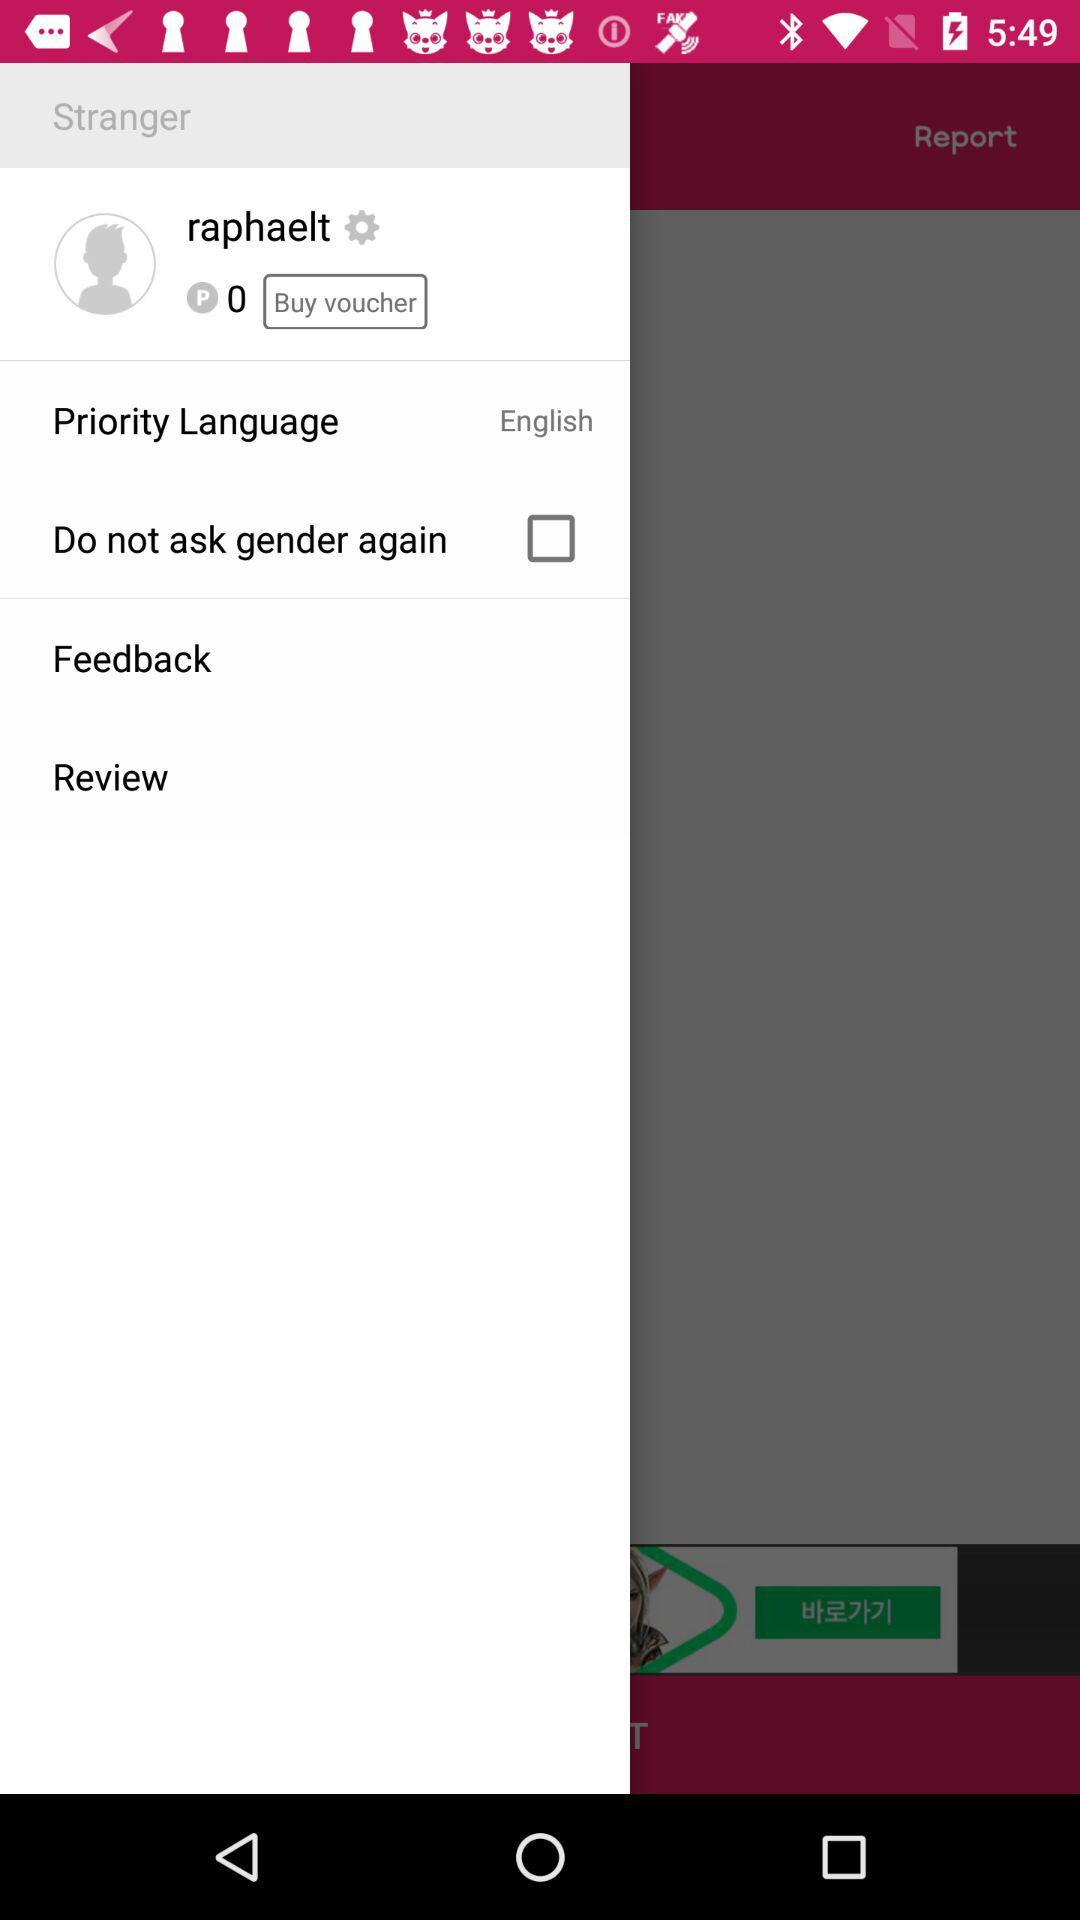What is the priority language? The priority language is English. 